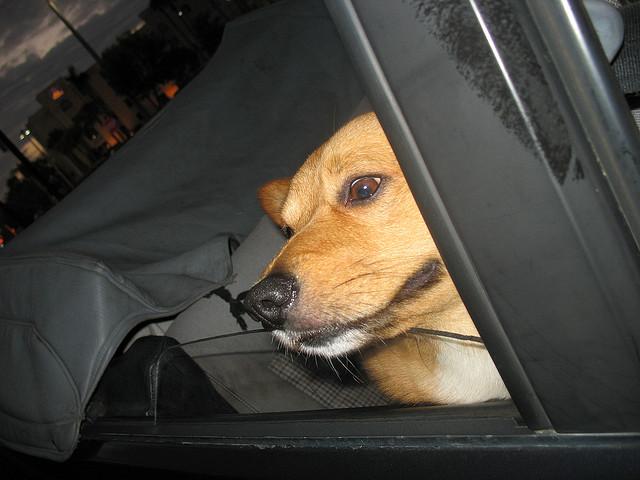What kind of vehicle is the dog in?
Concise answer only. Car. What is the dog looking out of?
Short answer required. Window. Is the background of a city?
Quick response, please. Yes. 